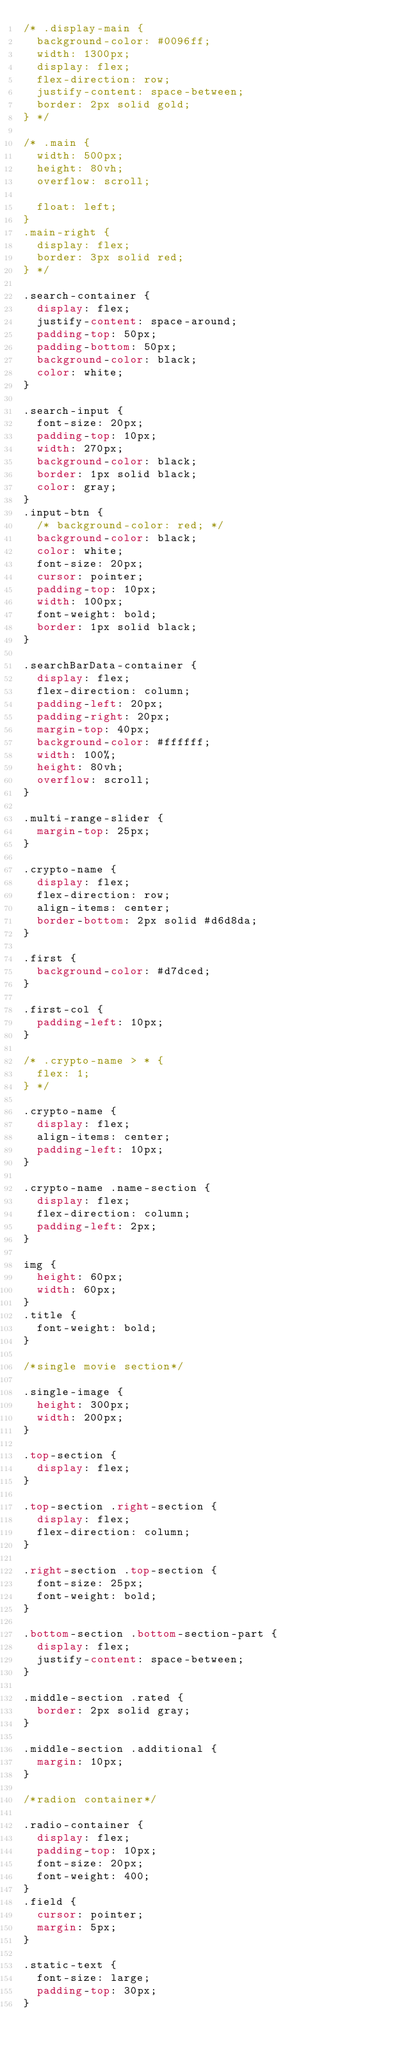Convert code to text. <code><loc_0><loc_0><loc_500><loc_500><_CSS_>/* .display-main {
  background-color: #0096ff;
  width: 1300px;
  display: flex;
  flex-direction: row;
  justify-content: space-between;
  border: 2px solid gold;
} */

/* .main {
  width: 500px;
  height: 80vh;
  overflow: scroll;

  float: left;
}
.main-right {
  display: flex;
  border: 3px solid red;
} */

.search-container {
  display: flex;
  justify-content: space-around;
  padding-top: 50px;
  padding-bottom: 50px;
  background-color: black;
  color: white;
}

.search-input {
  font-size: 20px;
  padding-top: 10px;
  width: 270px;
  background-color: black;
  border: 1px solid black;
  color: gray;
}
.input-btn {
  /* background-color: red; */
  background-color: black;
  color: white;
  font-size: 20px;
  cursor: pointer;
  padding-top: 10px;
  width: 100px;
  font-weight: bold;
  border: 1px solid black;
}

.searchBarData-container {
  display: flex;
  flex-direction: column;
  padding-left: 20px;
  padding-right: 20px;
  margin-top: 40px;
  background-color: #ffffff;
  width: 100%;
  height: 80vh;
  overflow: scroll;
}

.multi-range-slider {
  margin-top: 25px;
}

.crypto-name {
  display: flex;
  flex-direction: row;
  align-items: center;
  border-bottom: 2px solid #d6d8da;
}

.first {
  background-color: #d7dced;
}

.first-col {
  padding-left: 10px;
}

/* .crypto-name > * {
  flex: 1;
} */

.crypto-name {
  display: flex;
  align-items: center;
  padding-left: 10px;
}

.crypto-name .name-section {
  display: flex;
  flex-direction: column;
  padding-left: 2px;
}

img {
  height: 60px;
  width: 60px;
}
.title {
  font-weight: bold;
}

/*single movie section*/

.single-image {
  height: 300px;
  width: 200px;
}

.top-section {
  display: flex;
}

.top-section .right-section {
  display: flex;
  flex-direction: column;
}

.right-section .top-section {
  font-size: 25px;
  font-weight: bold;
}

.bottom-section .bottom-section-part {
  display: flex;
  justify-content: space-between;
}

.middle-section .rated {
  border: 2px solid gray;
}

.middle-section .additional {
  margin: 10px;
}

/*radion container*/

.radio-container {
  display: flex;
  padding-top: 10px;
  font-size: 20px;
  font-weight: 400;
}
.field {
  cursor: pointer;
  margin: 5px;
}

.static-text {
  font-size: large;
  padding-top: 30px;
}
</code> 